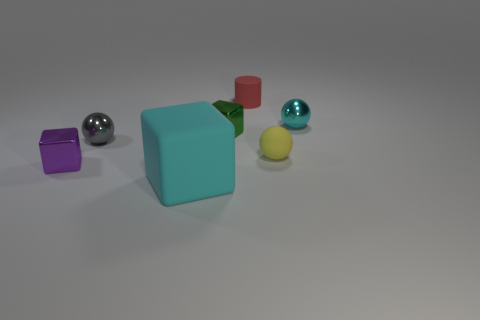Subtract all green metallic blocks. How many blocks are left? 2 Add 2 tiny metal things. How many objects exist? 9 Subtract all yellow spheres. How many spheres are left? 2 Subtract 3 spheres. How many spheres are left? 0 Add 7 purple things. How many purple things are left? 8 Add 7 large blue objects. How many large blue objects exist? 7 Subtract 0 yellow blocks. How many objects are left? 7 Subtract all cylinders. How many objects are left? 6 Subtract all yellow cubes. Subtract all red balls. How many cubes are left? 3 Subtract all blue cylinders. How many yellow blocks are left? 0 